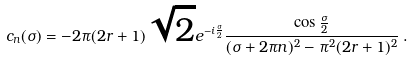<formula> <loc_0><loc_0><loc_500><loc_500>c _ { n } ( \sigma ) = - 2 \pi ( 2 r + 1 ) \sqrt { 2 } e ^ { - i \frac { \sigma } { 2 } } \frac { \cos { \frac { \sigma } { 2 } } } { ( \sigma + 2 \pi n ) ^ { 2 } - \pi ^ { 2 } ( 2 r + 1 ) ^ { 2 } } \, .</formula> 